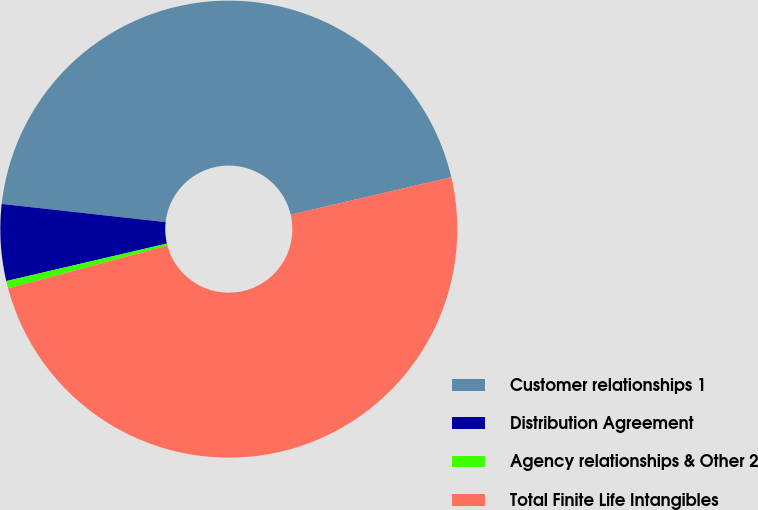<chart> <loc_0><loc_0><loc_500><loc_500><pie_chart><fcel>Customer relationships 1<fcel>Distribution Agreement<fcel>Agency relationships & Other 2<fcel>Total Finite Life Intangibles<nl><fcel>44.59%<fcel>5.41%<fcel>0.53%<fcel>49.47%<nl></chart> 